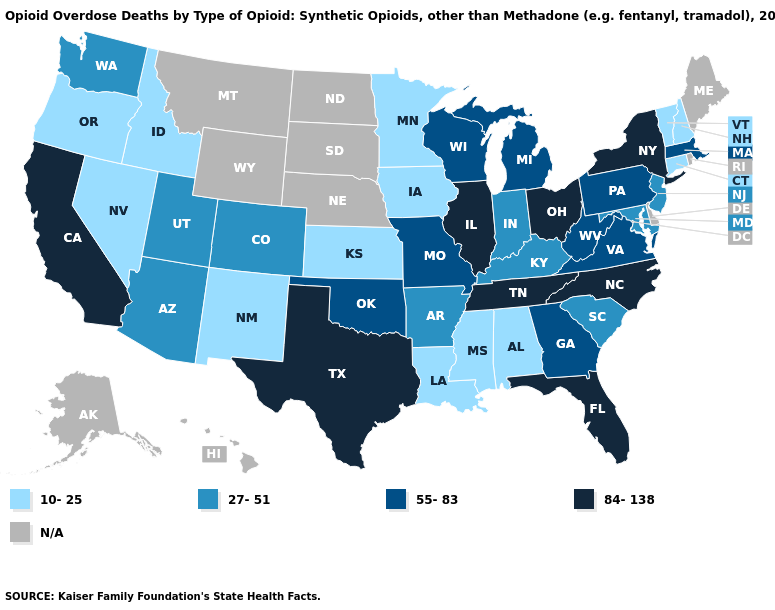Does Massachusetts have the highest value in the USA?
Keep it brief. No. Which states have the highest value in the USA?
Write a very short answer. California, Florida, Illinois, New York, North Carolina, Ohio, Tennessee, Texas. What is the lowest value in the West?
Write a very short answer. 10-25. Which states have the highest value in the USA?
Be succinct. California, Florida, Illinois, New York, North Carolina, Ohio, Tennessee, Texas. What is the lowest value in the USA?
Quick response, please. 10-25. Does the first symbol in the legend represent the smallest category?
Concise answer only. Yes. What is the highest value in the USA?
Concise answer only. 84-138. Name the states that have a value in the range 10-25?
Short answer required. Alabama, Connecticut, Idaho, Iowa, Kansas, Louisiana, Minnesota, Mississippi, Nevada, New Hampshire, New Mexico, Oregon, Vermont. Name the states that have a value in the range 27-51?
Concise answer only. Arizona, Arkansas, Colorado, Indiana, Kentucky, Maryland, New Jersey, South Carolina, Utah, Washington. Among the states that border Oklahoma , which have the lowest value?
Short answer required. Kansas, New Mexico. Does Texas have the highest value in the South?
Short answer required. Yes. What is the value of Massachusetts?
Give a very brief answer. 55-83. Does Virginia have the highest value in the South?
Answer briefly. No. 